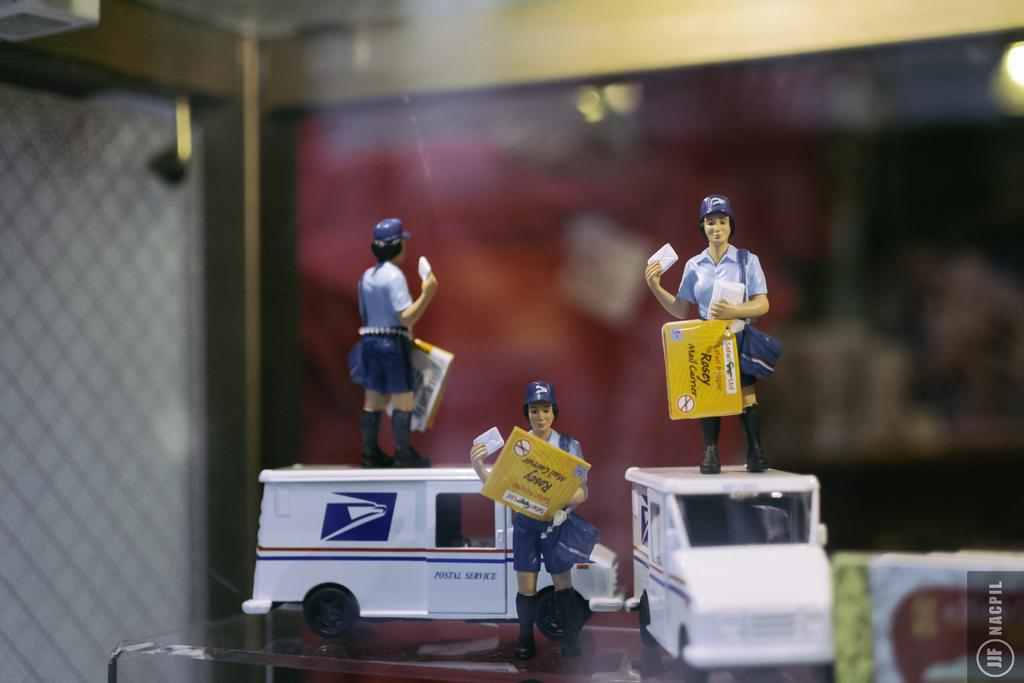What is the main subject of the image? The main subject of the image is toys. Where are the toys located in the image? The toys are in the center of the image. Can you describe the background of the image? The background of the image is blurry. What type of animal can be seen flying through the window in the image? There is no animal or window present in the image; it only features toys in the center with a blurry background. 